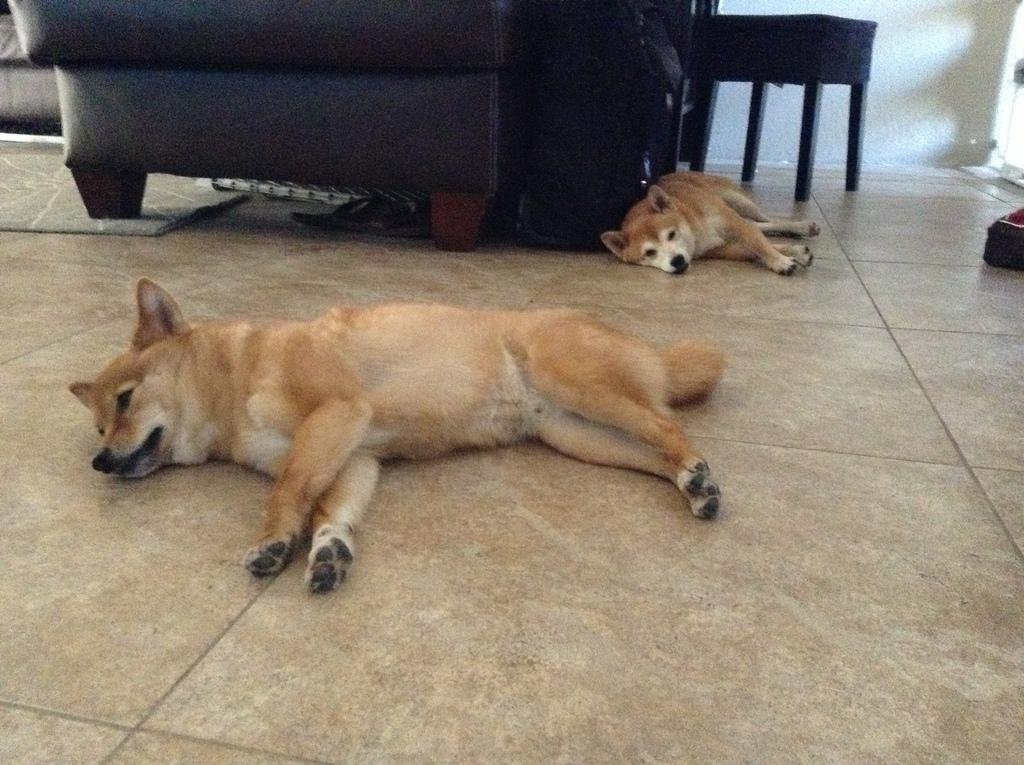How many dogs are present in the image? There are 2 dogs in the image. What position are the dogs in? The dogs are lying on the floor. What furniture can be seen in the background of the image? There is a couch and a chair in the background of the image. What type of seed can be seen growing on the dogs in the image? There are no seeds present in the image, and the dogs are not depicted as growing anything. 